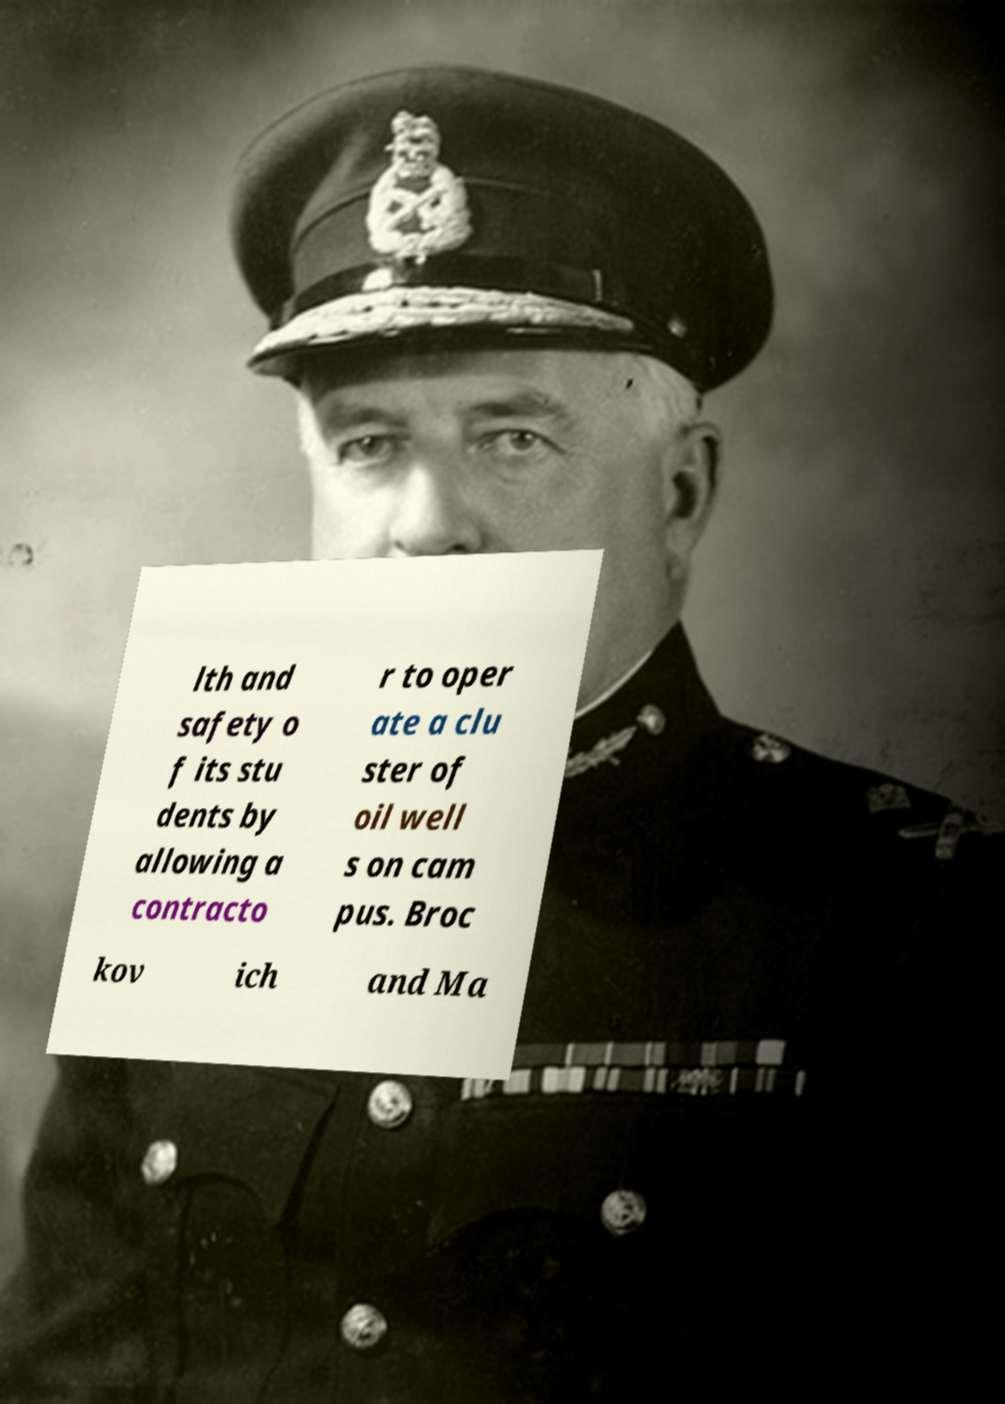For documentation purposes, I need the text within this image transcribed. Could you provide that? lth and safety o f its stu dents by allowing a contracto r to oper ate a clu ster of oil well s on cam pus. Broc kov ich and Ma 